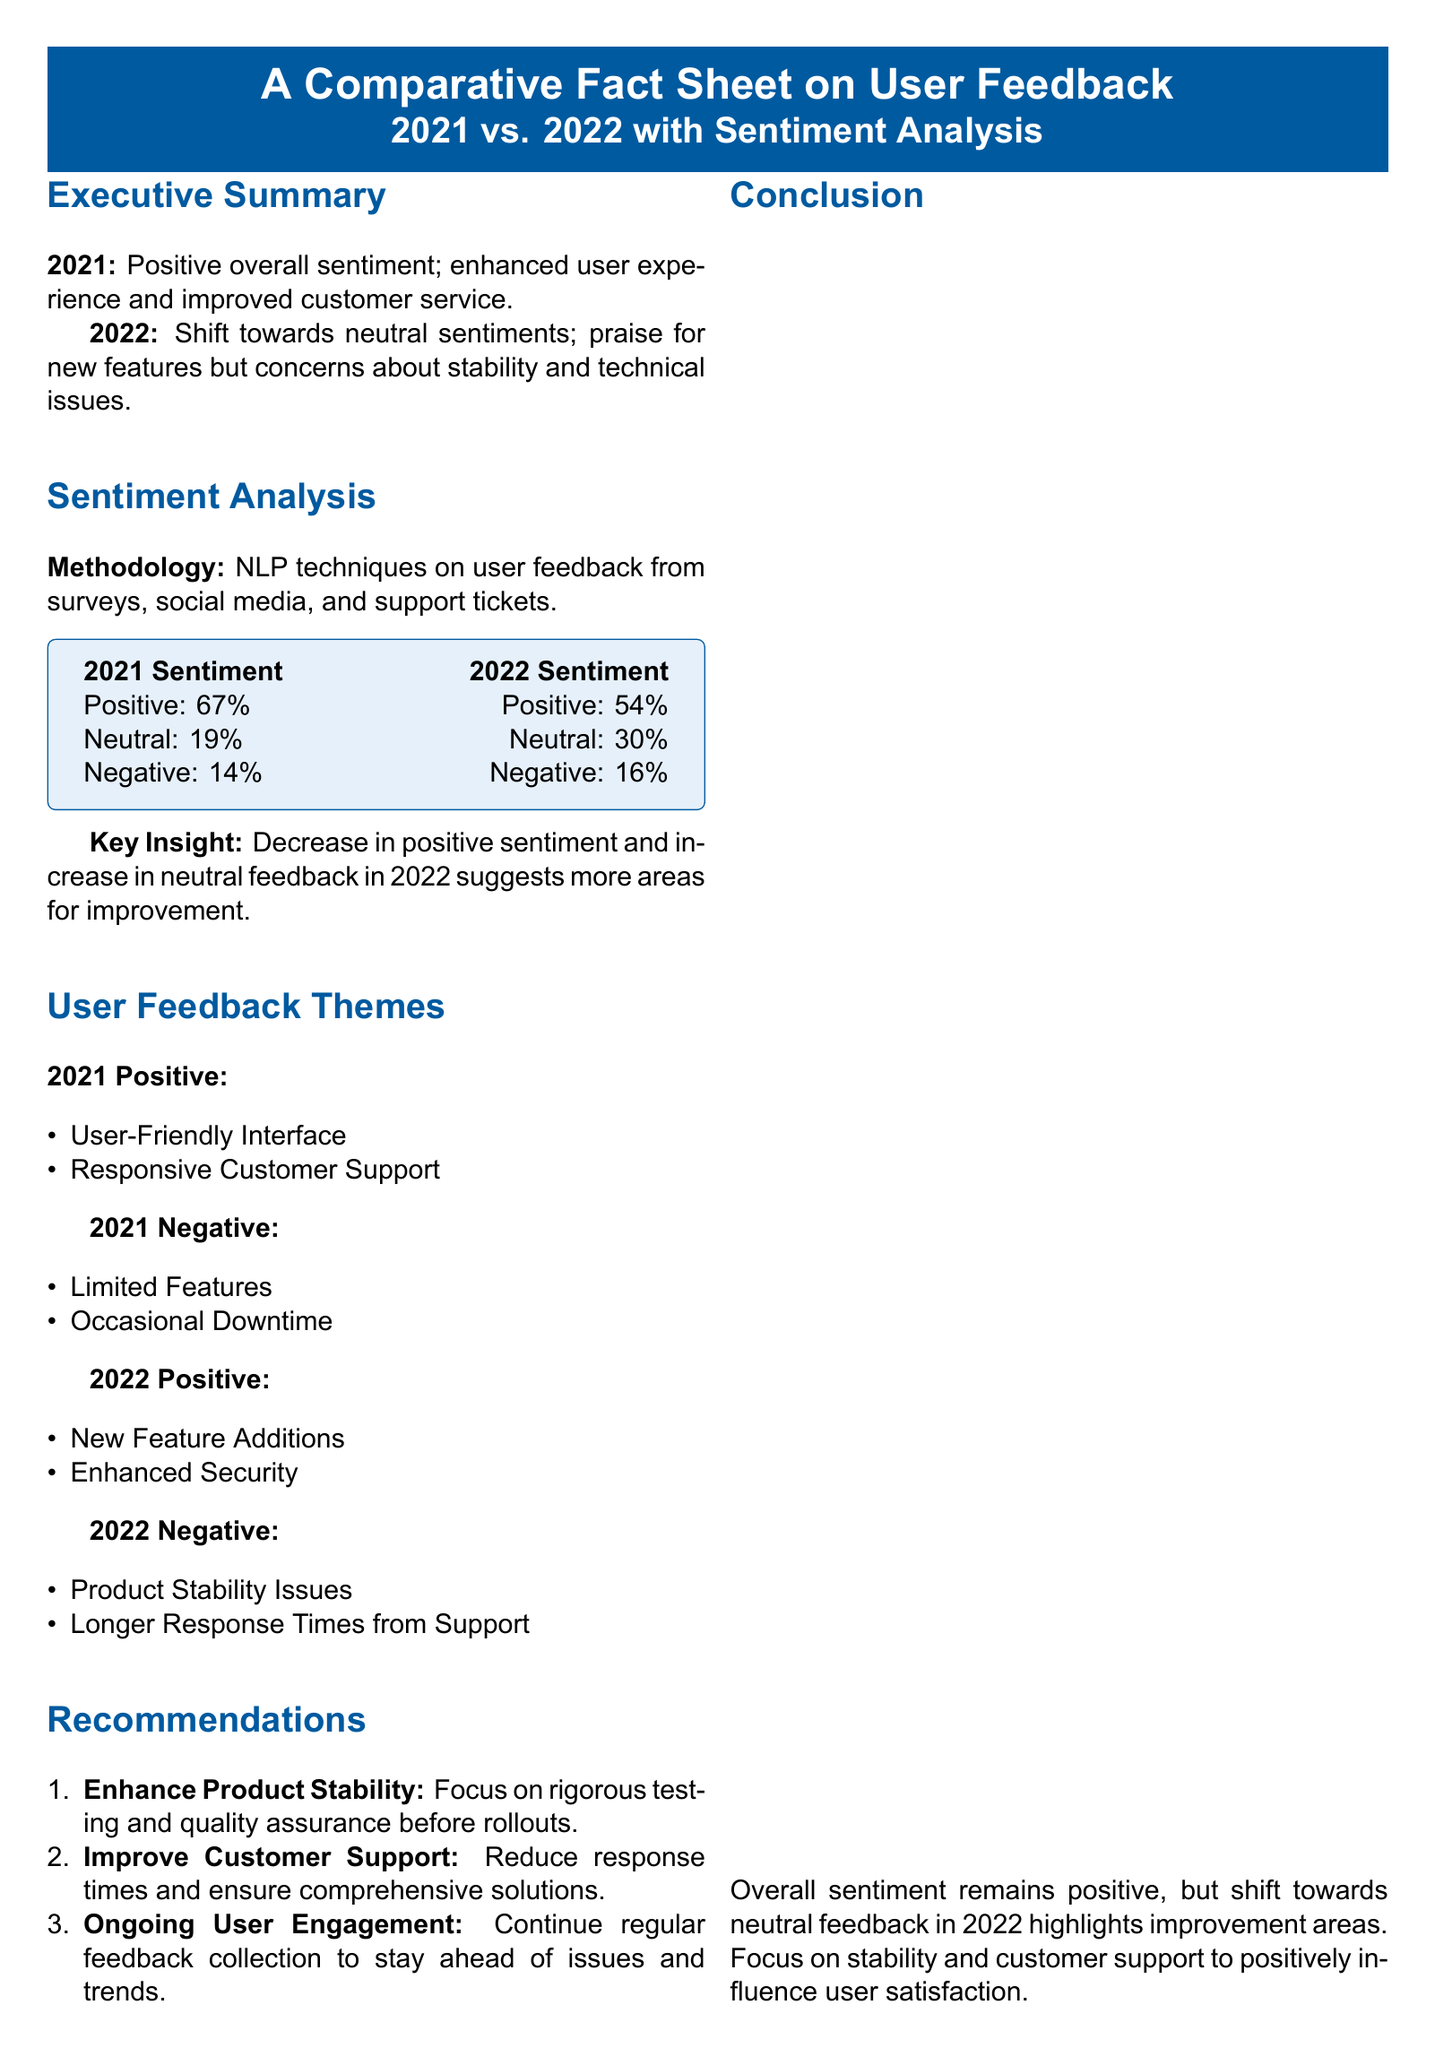What was the overall sentiment in 2021? The overall sentiment in 2021 was positive.
Answer: Positive What percentage of user feedback was neutral in 2022? The document states that 30% of user feedback in 2022 was neutral.
Answer: 30% What were the two positive themes in 2022? The positive themes in 2022 were new feature additions and enhanced security.
Answer: New Feature Additions, Enhanced Security What is one negative theme identified for 2021? The document lists limited features as one negative theme for 2021.
Answer: Limited Features What is the recommended action to improve customer support? The recommendation is to reduce response times and ensure comprehensive solutions.
Answer: Reduce response times Which sentiment category increased from 2021 to 2022? The neutral sentiment category increased from 19% in 2021 to 30% in 2022.
Answer: Neutral What is the primary data source mentioned? The primary data source mentioned is the Company User Feedback Survey.
Answer: Company User Feedback Survey What was the percentage of positive sentiment in 2021? The document states that 67% of user feedback was positive in 2021.
Answer: 67% 